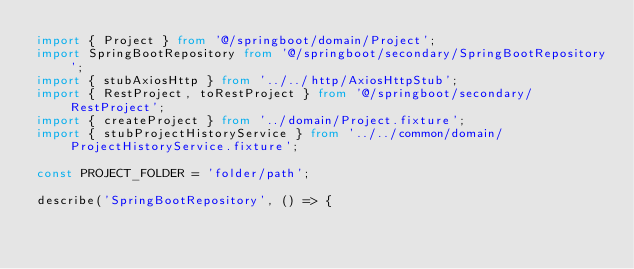Convert code to text. <code><loc_0><loc_0><loc_500><loc_500><_TypeScript_>import { Project } from '@/springboot/domain/Project';
import SpringBootRepository from '@/springboot/secondary/SpringBootRepository';
import { stubAxiosHttp } from '../../http/AxiosHttpStub';
import { RestProject, toRestProject } from '@/springboot/secondary/RestProject';
import { createProject } from '../domain/Project.fixture';
import { stubProjectHistoryService } from '../../common/domain/ProjectHistoryService.fixture';

const PROJECT_FOLDER = 'folder/path';

describe('SpringBootRepository', () => {</code> 